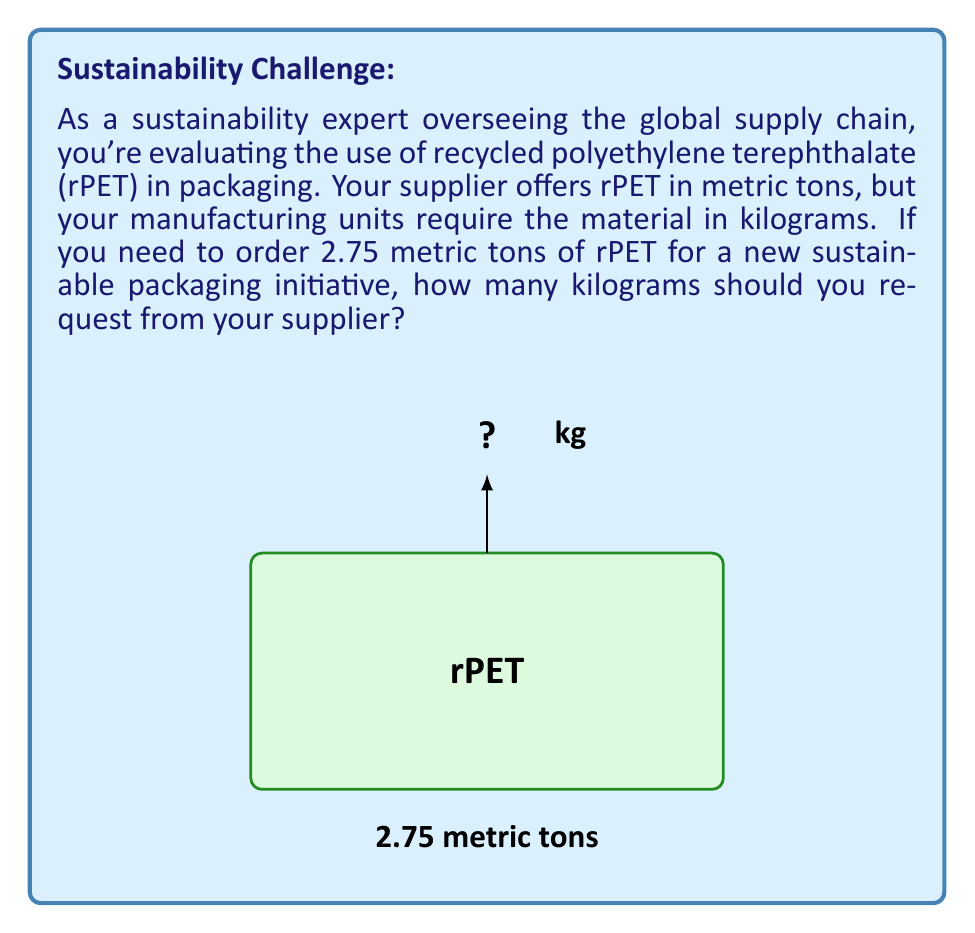What is the answer to this math problem? To solve this problem, we need to convert metric tons to kilograms. Let's break it down step-by-step:

1) First, recall the conversion factor:
   1 metric ton = 1000 kilograms

2) We can express this as an equation:
   $$ 1 \text{ metric ton} = 1000 \text{ kg} $$

3) Now, we need to convert 2.75 metric tons. We can set up a proportion:
   $$ \frac{1 \text{ metric ton}}{1000 \text{ kg}} = \frac{2.75 \text{ metric tons}}{x \text{ kg}} $$

4) Cross multiply:
   $$ 1 \cdot x = 1000 \cdot 2.75 $$

5) Solve for x:
   $$ x = 1000 \cdot 2.75 = 2750 $$

Therefore, 2.75 metric tons is equivalent to 2750 kilograms.
Answer: 2750 kg 